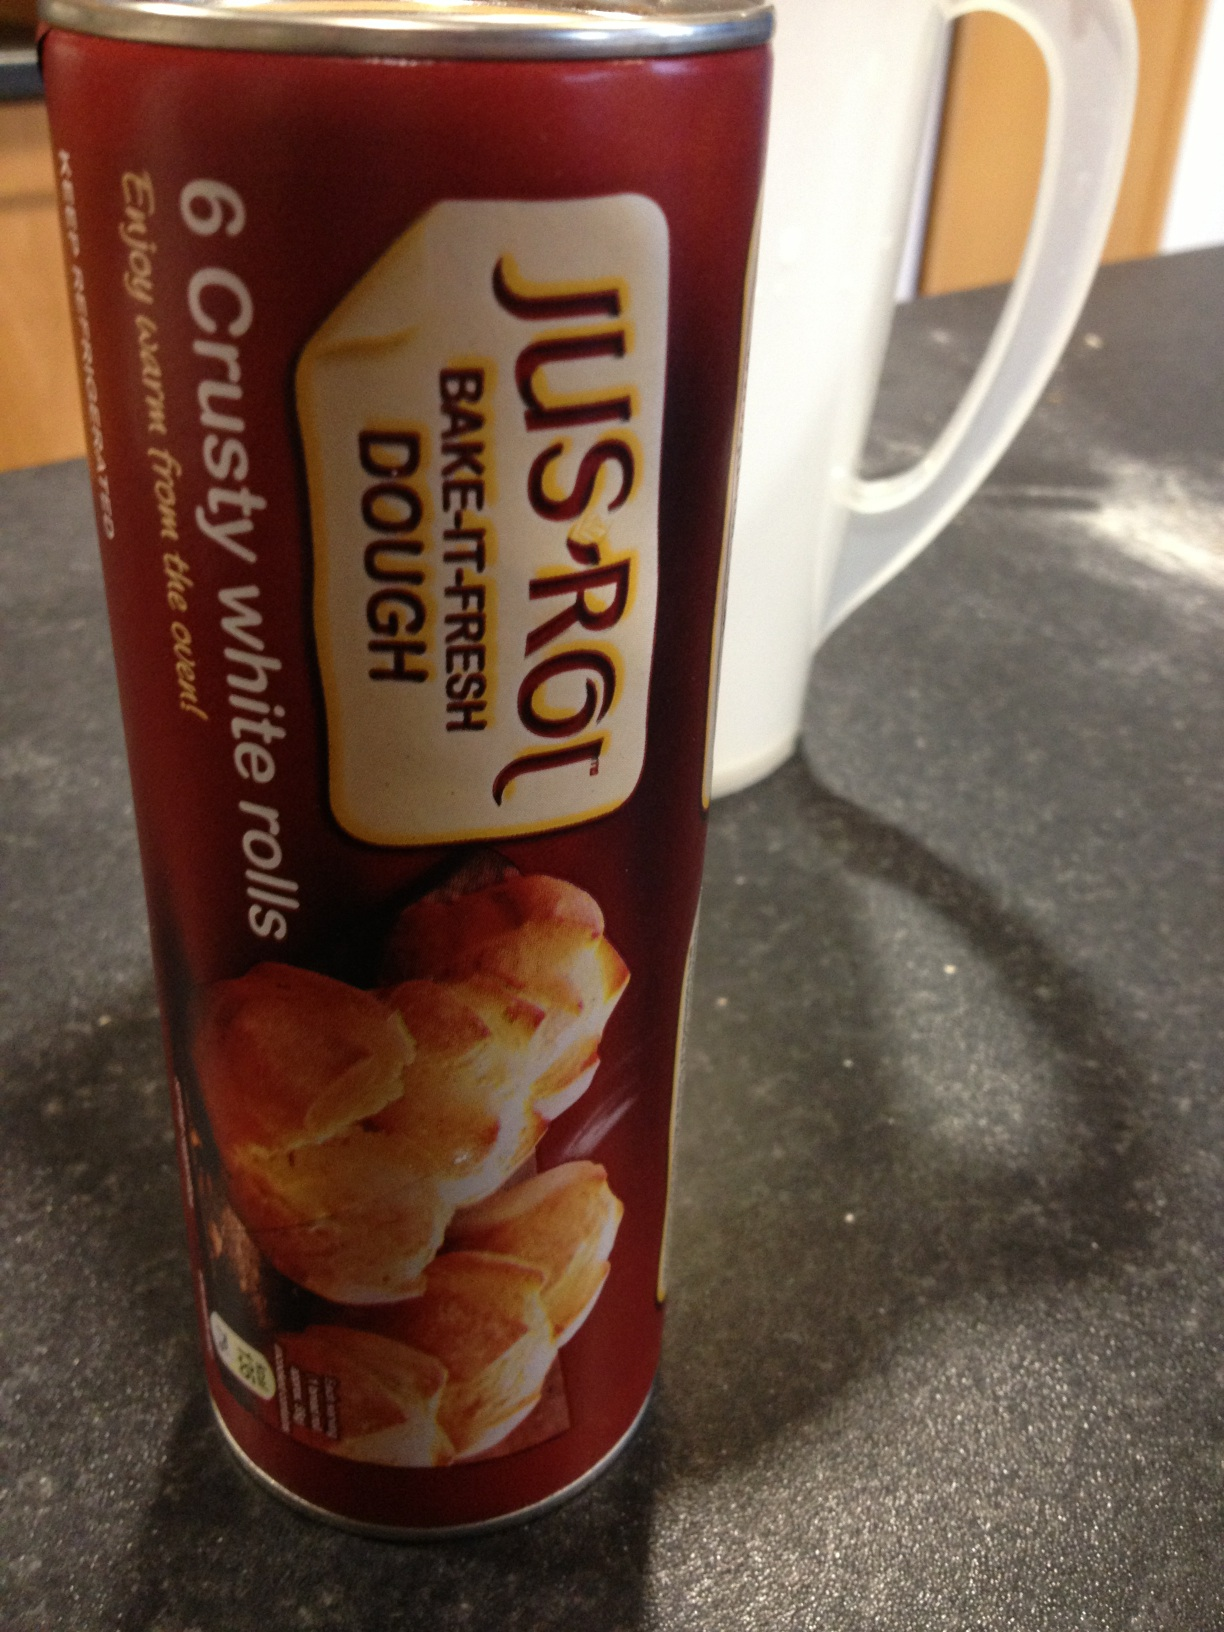What's the history and origin of white rolls? The history of white rolls dates back centuries, with their popularity rising in Europe, particularly in France and Germany where breadmaking has a long tradition. White rolls are made from refined white flour, which became more commonly available and popular with the advent of industrial milling in the 19th century. These rolls have remained a staple in many cultures due to their soft, fluffy texture and mild flavor, making them a popular choice for breakfast, sandwiches, and as accompaniments to meals. 